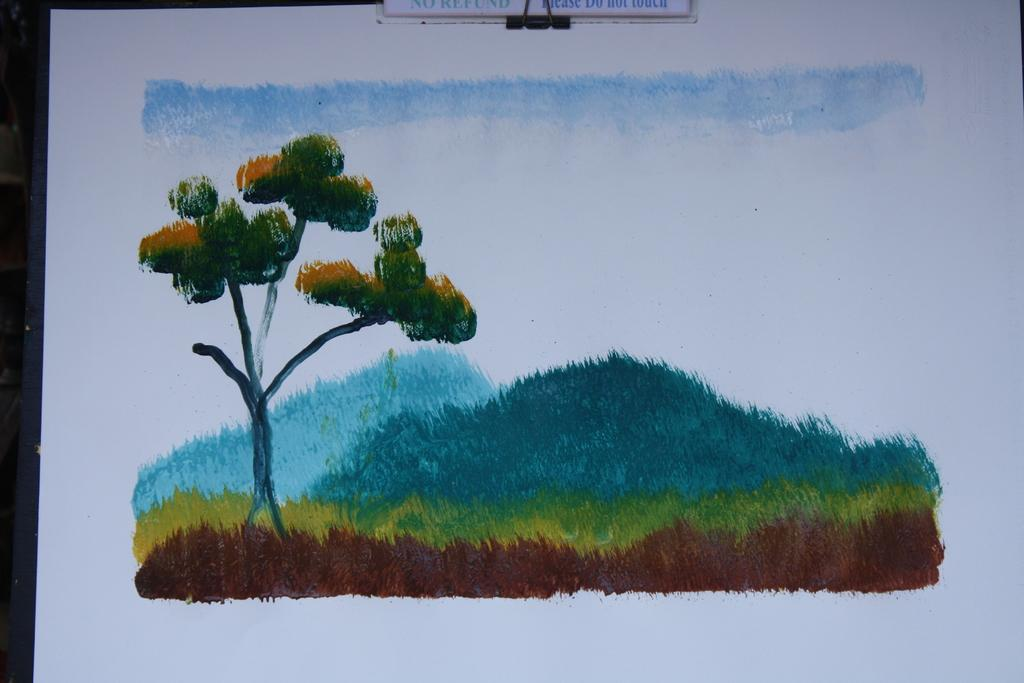What is depicted on the paper in the image? There is a painting on a paper in the image. What elements are included in the painting? The painting includes grass, a tree, and the sky. What type of toothbrush is shown in the painting? There is no toothbrush present in the painting; it only includes grass, a tree, and the sky. 